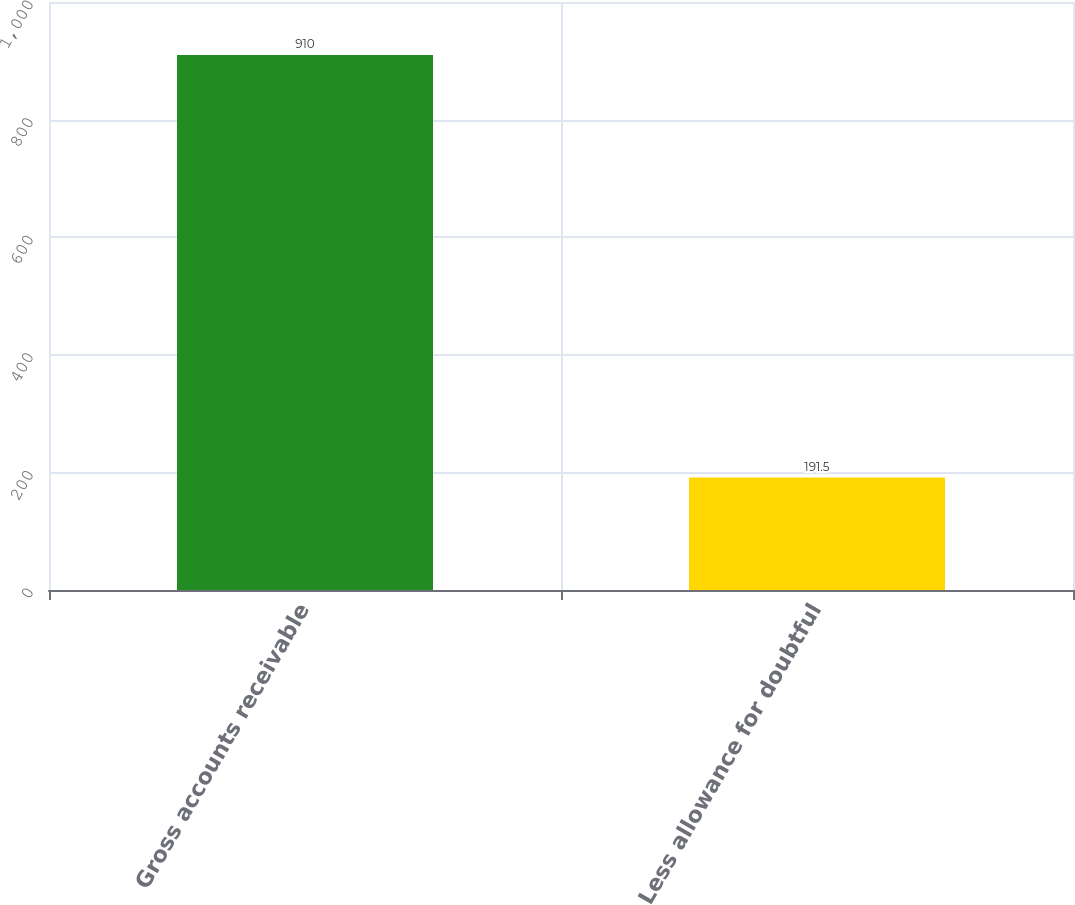Convert chart to OTSL. <chart><loc_0><loc_0><loc_500><loc_500><bar_chart><fcel>Gross accounts receivable<fcel>Less allowance for doubtful<nl><fcel>910<fcel>191.5<nl></chart> 